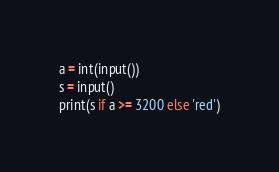Convert code to text. <code><loc_0><loc_0><loc_500><loc_500><_Python_>a = int(input())
s = input()
print(s if a >= 3200 else 'red')</code> 